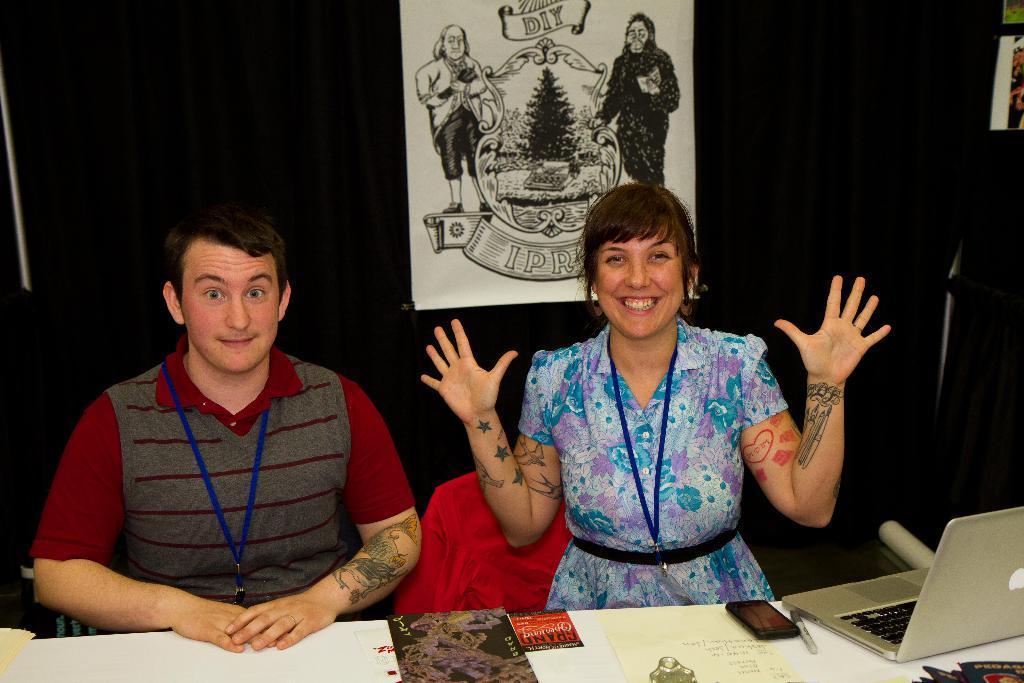Describe this image in one or two sentences. In this image we can see a man and a woman sitting on the chairs and a table is placed in front of them. On the table we can see laptop, market, mobile phone, papers and an advertisement. In the background there is a curtain and a picture attached to it. 